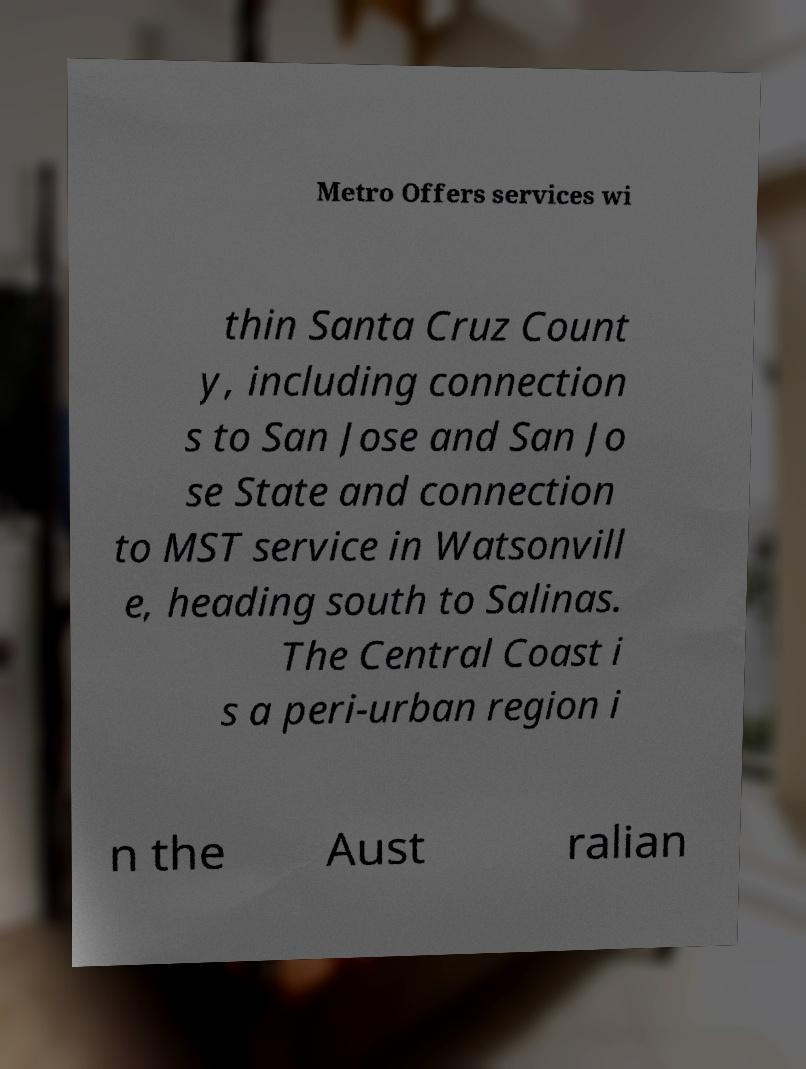Can you accurately transcribe the text from the provided image for me? Metro Offers services wi thin Santa Cruz Count y, including connection s to San Jose and San Jo se State and connection to MST service in Watsonvill e, heading south to Salinas. The Central Coast i s a peri-urban region i n the Aust ralian 